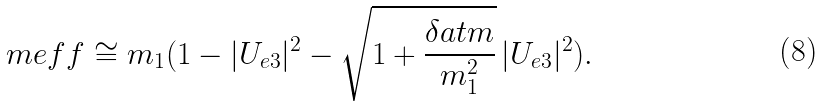Convert formula to latex. <formula><loc_0><loc_0><loc_500><loc_500>\ m e f f \cong m _ { 1 } ( 1 - | U _ { e 3 } | ^ { 2 } - \sqrt { 1 + \frac { \delta a t m } { m ^ { 2 } _ { 1 } } } \, | U _ { e 3 } | ^ { 2 } ) .</formula> 